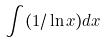Convert formula to latex. <formula><loc_0><loc_0><loc_500><loc_500>\int ( 1 / \ln x ) d x</formula> 